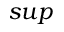<formula> <loc_0><loc_0><loc_500><loc_500>s u p</formula> 